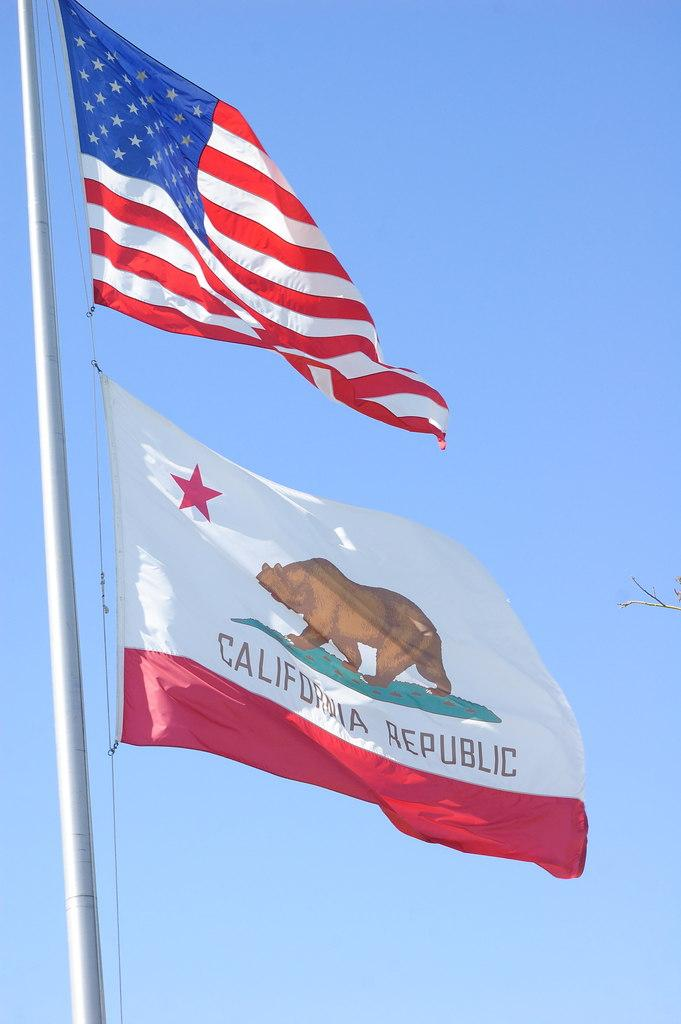What objects are present in the image that represent a country or organization? There are flags in the image. How are the flags positioned in the image? The flags are attached to a pole. What can be seen in the background of the image? There is sky visible in the background of the image. How many goldfish can be seen swimming on the floor in the image? There are no goldfish present in the image, and the floor is not visible. 